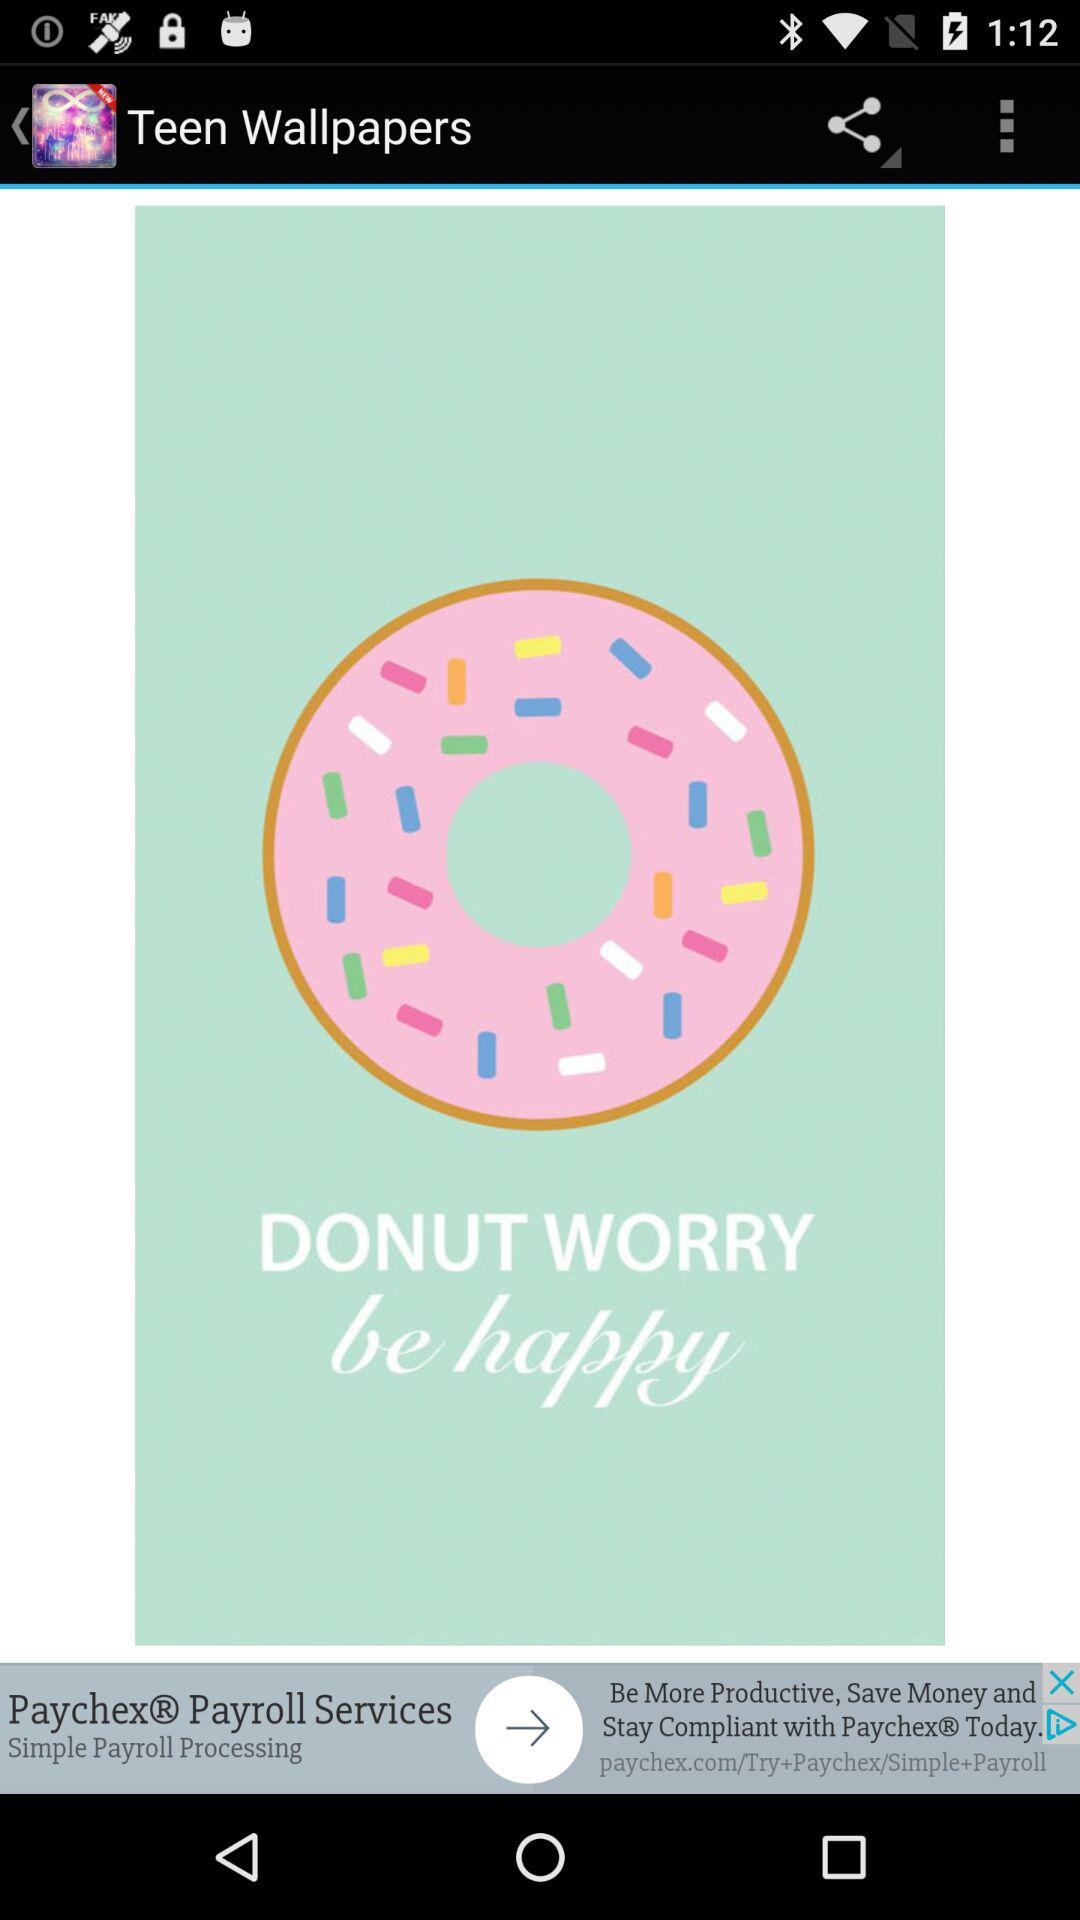What is the application name? The application name is "Teen Wallpapers". 